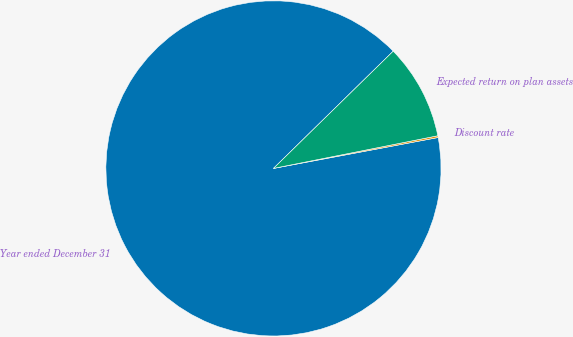Convert chart. <chart><loc_0><loc_0><loc_500><loc_500><pie_chart><fcel>Year ended December 31<fcel>Discount rate<fcel>Expected return on plan assets<nl><fcel>90.62%<fcel>0.17%<fcel>9.21%<nl></chart> 